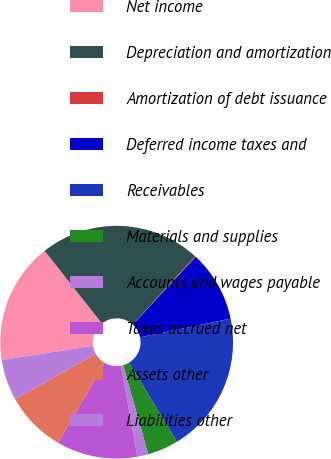Convert chart. <chart><loc_0><loc_0><loc_500><loc_500><pie_chart><fcel>Net income<fcel>Depreciation and amortization<fcel>Amortization of debt issuance<fcel>Deferred income taxes and<fcel>Receivables<fcel>Materials and supplies<fcel>Accounts and wages payable<fcel>Taxes accrued net<fcel>Assets other<fcel>Liabilities other<nl><fcel>16.82%<fcel>22.39%<fcel>0.12%<fcel>9.86%<fcel>19.6%<fcel>4.29%<fcel>1.51%<fcel>11.25%<fcel>8.47%<fcel>5.69%<nl></chart> 